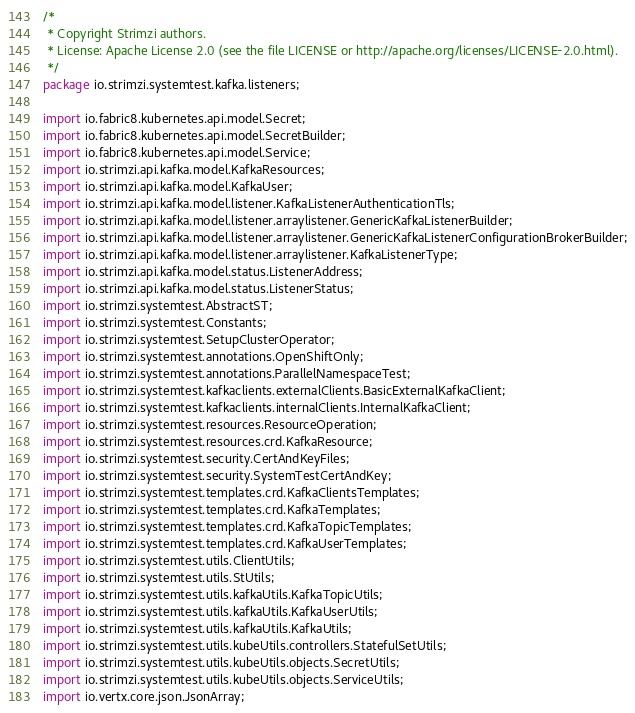Convert code to text. <code><loc_0><loc_0><loc_500><loc_500><_Java_>/*
 * Copyright Strimzi authors.
 * License: Apache License 2.0 (see the file LICENSE or http://apache.org/licenses/LICENSE-2.0.html).
 */
package io.strimzi.systemtest.kafka.listeners;

import io.fabric8.kubernetes.api.model.Secret;
import io.fabric8.kubernetes.api.model.SecretBuilder;
import io.fabric8.kubernetes.api.model.Service;
import io.strimzi.api.kafka.model.KafkaResources;
import io.strimzi.api.kafka.model.KafkaUser;
import io.strimzi.api.kafka.model.listener.KafkaListenerAuthenticationTls;
import io.strimzi.api.kafka.model.listener.arraylistener.GenericKafkaListenerBuilder;
import io.strimzi.api.kafka.model.listener.arraylistener.GenericKafkaListenerConfigurationBrokerBuilder;
import io.strimzi.api.kafka.model.listener.arraylistener.KafkaListenerType;
import io.strimzi.api.kafka.model.status.ListenerAddress;
import io.strimzi.api.kafka.model.status.ListenerStatus;
import io.strimzi.systemtest.AbstractST;
import io.strimzi.systemtest.Constants;
import io.strimzi.systemtest.SetupClusterOperator;
import io.strimzi.systemtest.annotations.OpenShiftOnly;
import io.strimzi.systemtest.annotations.ParallelNamespaceTest;
import io.strimzi.systemtest.kafkaclients.externalClients.BasicExternalKafkaClient;
import io.strimzi.systemtest.kafkaclients.internalClients.InternalKafkaClient;
import io.strimzi.systemtest.resources.ResourceOperation;
import io.strimzi.systemtest.resources.crd.KafkaResource;
import io.strimzi.systemtest.security.CertAndKeyFiles;
import io.strimzi.systemtest.security.SystemTestCertAndKey;
import io.strimzi.systemtest.templates.crd.KafkaClientsTemplates;
import io.strimzi.systemtest.templates.crd.KafkaTemplates;
import io.strimzi.systemtest.templates.crd.KafkaTopicTemplates;
import io.strimzi.systemtest.templates.crd.KafkaUserTemplates;
import io.strimzi.systemtest.utils.ClientUtils;
import io.strimzi.systemtest.utils.StUtils;
import io.strimzi.systemtest.utils.kafkaUtils.KafkaTopicUtils;
import io.strimzi.systemtest.utils.kafkaUtils.KafkaUserUtils;
import io.strimzi.systemtest.utils.kafkaUtils.KafkaUtils;
import io.strimzi.systemtest.utils.kubeUtils.controllers.StatefulSetUtils;
import io.strimzi.systemtest.utils.kubeUtils.objects.SecretUtils;
import io.strimzi.systemtest.utils.kubeUtils.objects.ServiceUtils;
import io.vertx.core.json.JsonArray;</code> 